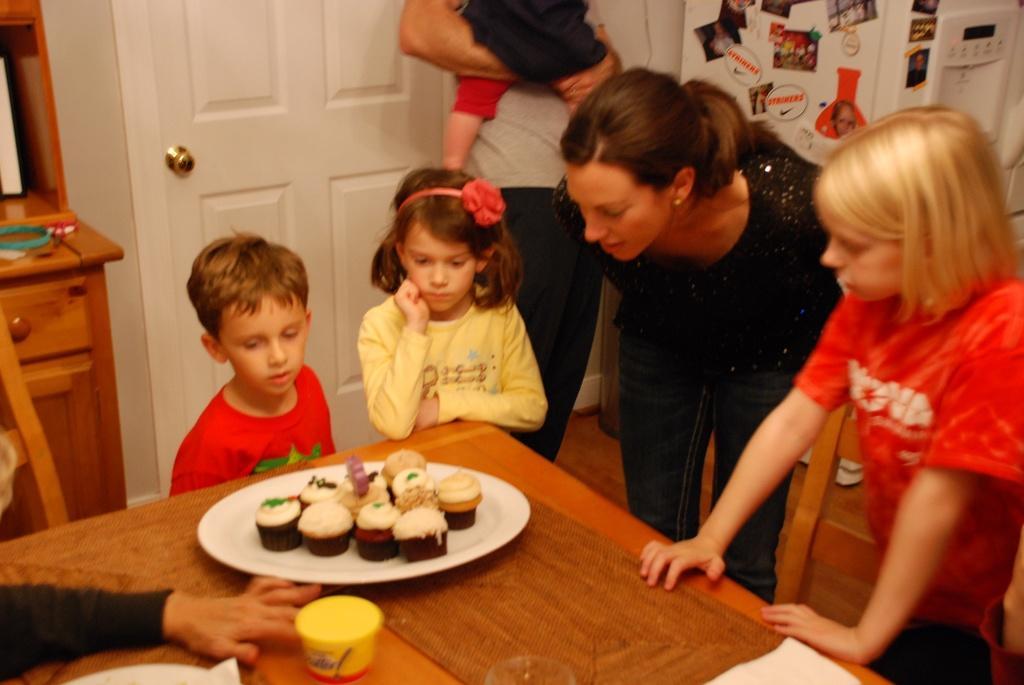Could you give a brief overview of what you see in this image? There are people standing and we can see plate with muffins,hand,glass,mat and objects on the table. In the background we can see a person holding a kid,photos on the surface,furniture and door. 